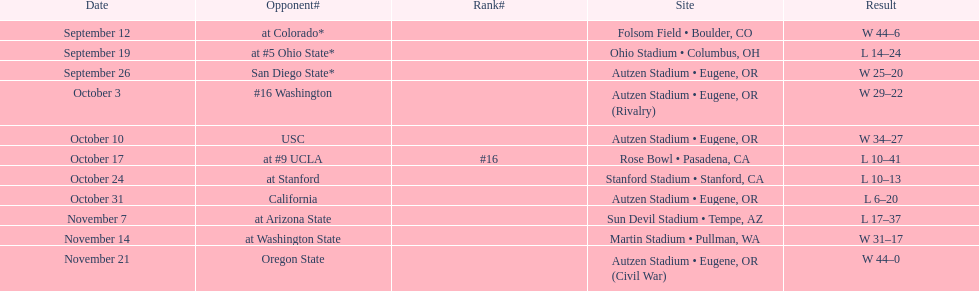What is the number of away games ? 6. 